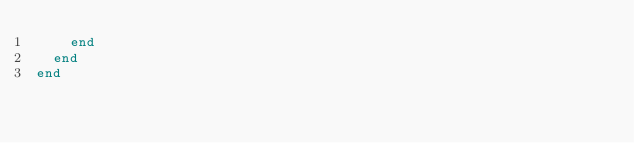Convert code to text. <code><loc_0><loc_0><loc_500><loc_500><_Ruby_>    end
  end
end
</code> 